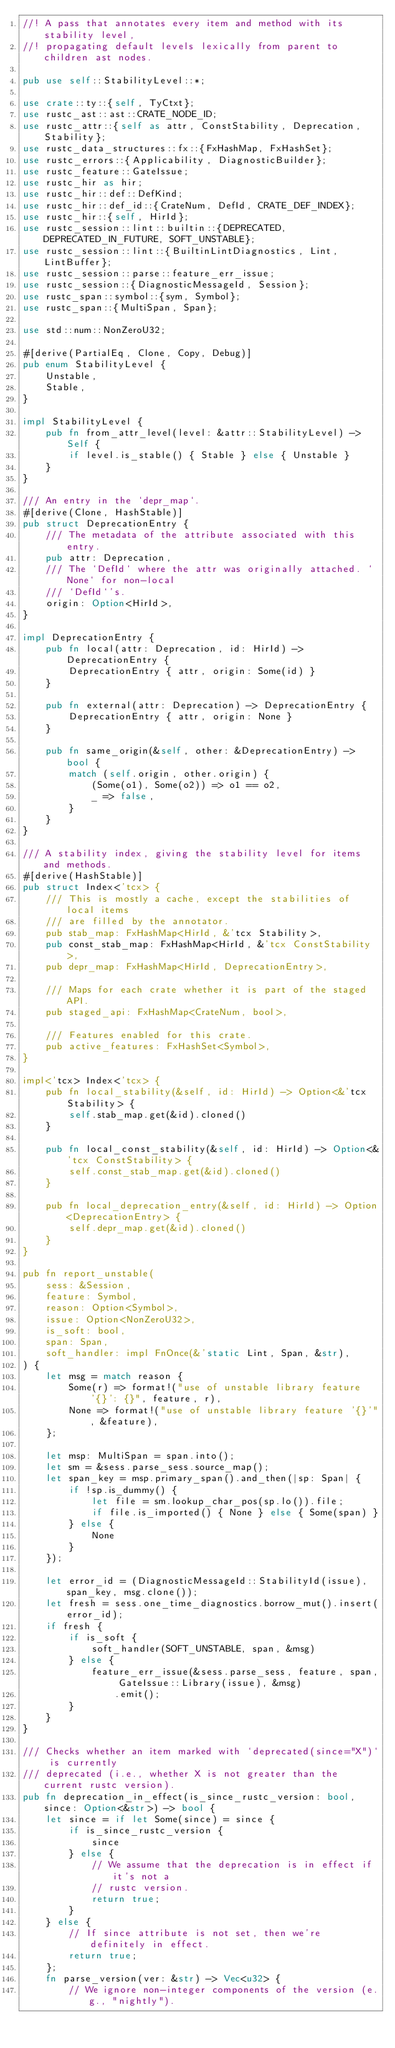<code> <loc_0><loc_0><loc_500><loc_500><_Rust_>//! A pass that annotates every item and method with its stability level,
//! propagating default levels lexically from parent to children ast nodes.

pub use self::StabilityLevel::*;

use crate::ty::{self, TyCtxt};
use rustc_ast::ast::CRATE_NODE_ID;
use rustc_attr::{self as attr, ConstStability, Deprecation, Stability};
use rustc_data_structures::fx::{FxHashMap, FxHashSet};
use rustc_errors::{Applicability, DiagnosticBuilder};
use rustc_feature::GateIssue;
use rustc_hir as hir;
use rustc_hir::def::DefKind;
use rustc_hir::def_id::{CrateNum, DefId, CRATE_DEF_INDEX};
use rustc_hir::{self, HirId};
use rustc_session::lint::builtin::{DEPRECATED, DEPRECATED_IN_FUTURE, SOFT_UNSTABLE};
use rustc_session::lint::{BuiltinLintDiagnostics, Lint, LintBuffer};
use rustc_session::parse::feature_err_issue;
use rustc_session::{DiagnosticMessageId, Session};
use rustc_span::symbol::{sym, Symbol};
use rustc_span::{MultiSpan, Span};

use std::num::NonZeroU32;

#[derive(PartialEq, Clone, Copy, Debug)]
pub enum StabilityLevel {
    Unstable,
    Stable,
}

impl StabilityLevel {
    pub fn from_attr_level(level: &attr::StabilityLevel) -> Self {
        if level.is_stable() { Stable } else { Unstable }
    }
}

/// An entry in the `depr_map`.
#[derive(Clone, HashStable)]
pub struct DeprecationEntry {
    /// The metadata of the attribute associated with this entry.
    pub attr: Deprecation,
    /// The `DefId` where the attr was originally attached. `None` for non-local
    /// `DefId`'s.
    origin: Option<HirId>,
}

impl DeprecationEntry {
    pub fn local(attr: Deprecation, id: HirId) -> DeprecationEntry {
        DeprecationEntry { attr, origin: Some(id) }
    }

    pub fn external(attr: Deprecation) -> DeprecationEntry {
        DeprecationEntry { attr, origin: None }
    }

    pub fn same_origin(&self, other: &DeprecationEntry) -> bool {
        match (self.origin, other.origin) {
            (Some(o1), Some(o2)) => o1 == o2,
            _ => false,
        }
    }
}

/// A stability index, giving the stability level for items and methods.
#[derive(HashStable)]
pub struct Index<'tcx> {
    /// This is mostly a cache, except the stabilities of local items
    /// are filled by the annotator.
    pub stab_map: FxHashMap<HirId, &'tcx Stability>,
    pub const_stab_map: FxHashMap<HirId, &'tcx ConstStability>,
    pub depr_map: FxHashMap<HirId, DeprecationEntry>,

    /// Maps for each crate whether it is part of the staged API.
    pub staged_api: FxHashMap<CrateNum, bool>,

    /// Features enabled for this crate.
    pub active_features: FxHashSet<Symbol>,
}

impl<'tcx> Index<'tcx> {
    pub fn local_stability(&self, id: HirId) -> Option<&'tcx Stability> {
        self.stab_map.get(&id).cloned()
    }

    pub fn local_const_stability(&self, id: HirId) -> Option<&'tcx ConstStability> {
        self.const_stab_map.get(&id).cloned()
    }

    pub fn local_deprecation_entry(&self, id: HirId) -> Option<DeprecationEntry> {
        self.depr_map.get(&id).cloned()
    }
}

pub fn report_unstable(
    sess: &Session,
    feature: Symbol,
    reason: Option<Symbol>,
    issue: Option<NonZeroU32>,
    is_soft: bool,
    span: Span,
    soft_handler: impl FnOnce(&'static Lint, Span, &str),
) {
    let msg = match reason {
        Some(r) => format!("use of unstable library feature '{}': {}", feature, r),
        None => format!("use of unstable library feature '{}'", &feature),
    };

    let msp: MultiSpan = span.into();
    let sm = &sess.parse_sess.source_map();
    let span_key = msp.primary_span().and_then(|sp: Span| {
        if !sp.is_dummy() {
            let file = sm.lookup_char_pos(sp.lo()).file;
            if file.is_imported() { None } else { Some(span) }
        } else {
            None
        }
    });

    let error_id = (DiagnosticMessageId::StabilityId(issue), span_key, msg.clone());
    let fresh = sess.one_time_diagnostics.borrow_mut().insert(error_id);
    if fresh {
        if is_soft {
            soft_handler(SOFT_UNSTABLE, span, &msg)
        } else {
            feature_err_issue(&sess.parse_sess, feature, span, GateIssue::Library(issue), &msg)
                .emit();
        }
    }
}

/// Checks whether an item marked with `deprecated(since="X")` is currently
/// deprecated (i.e., whether X is not greater than the current rustc version).
pub fn deprecation_in_effect(is_since_rustc_version: bool, since: Option<&str>) -> bool {
    let since = if let Some(since) = since {
        if is_since_rustc_version {
            since
        } else {
            // We assume that the deprecation is in effect if it's not a
            // rustc version.
            return true;
        }
    } else {
        // If since attribute is not set, then we're definitely in effect.
        return true;
    };
    fn parse_version(ver: &str) -> Vec<u32> {
        // We ignore non-integer components of the version (e.g., "nightly").</code> 